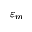Convert formula to latex. <formula><loc_0><loc_0><loc_500><loc_500>\varepsilon _ { m }</formula> 